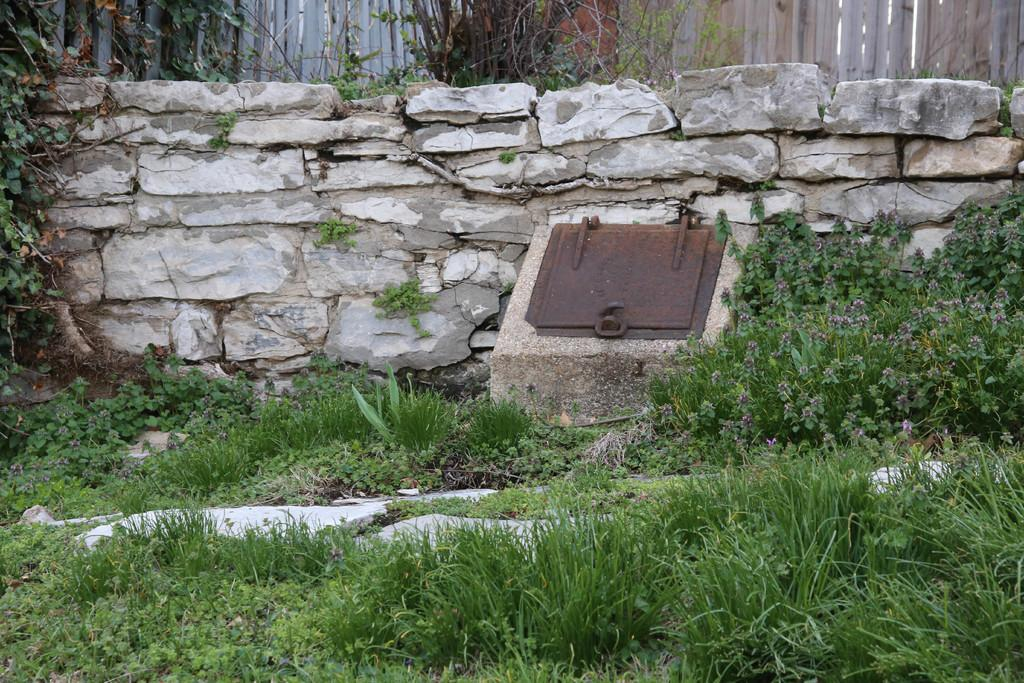What type of vegetation can be seen in the image? There is grass, plants, and trees in the image. What structures are present in the image? There is a fence in the image. What can be seen in the background of the image? There is a wall in the background of the image. How many types of vegetation can be identified in the image? There are three types of vegetation: grass, plants, and trees. Can you see a mountain in the image? No, there is no mountain present in the image. What type of bucket is being used by the plants in the image? There are no buckets present in the image. 